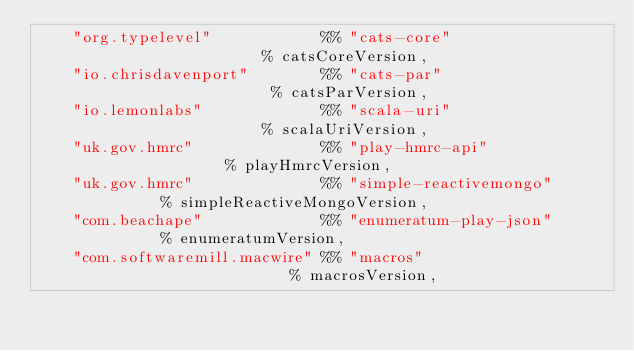Convert code to text. <code><loc_0><loc_0><loc_500><loc_500><_Scala_>    "org.typelevel"            %% "cats-core"                  % catsCoreVersion,
    "io.chrisdavenport"        %% "cats-par"                   % catsParVersion,
    "io.lemonlabs"             %% "scala-uri"                  % scalaUriVersion,
    "uk.gov.hmrc"              %% "play-hmrc-api"              % playHmrcVersion,
    "uk.gov.hmrc"              %% "simple-reactivemongo"       % simpleReactiveMongoVersion,
    "com.beachape"             %% "enumeratum-play-json"       % enumeratumVersion,
    "com.softwaremill.macwire" %% "macros"                     % macrosVersion,</code> 